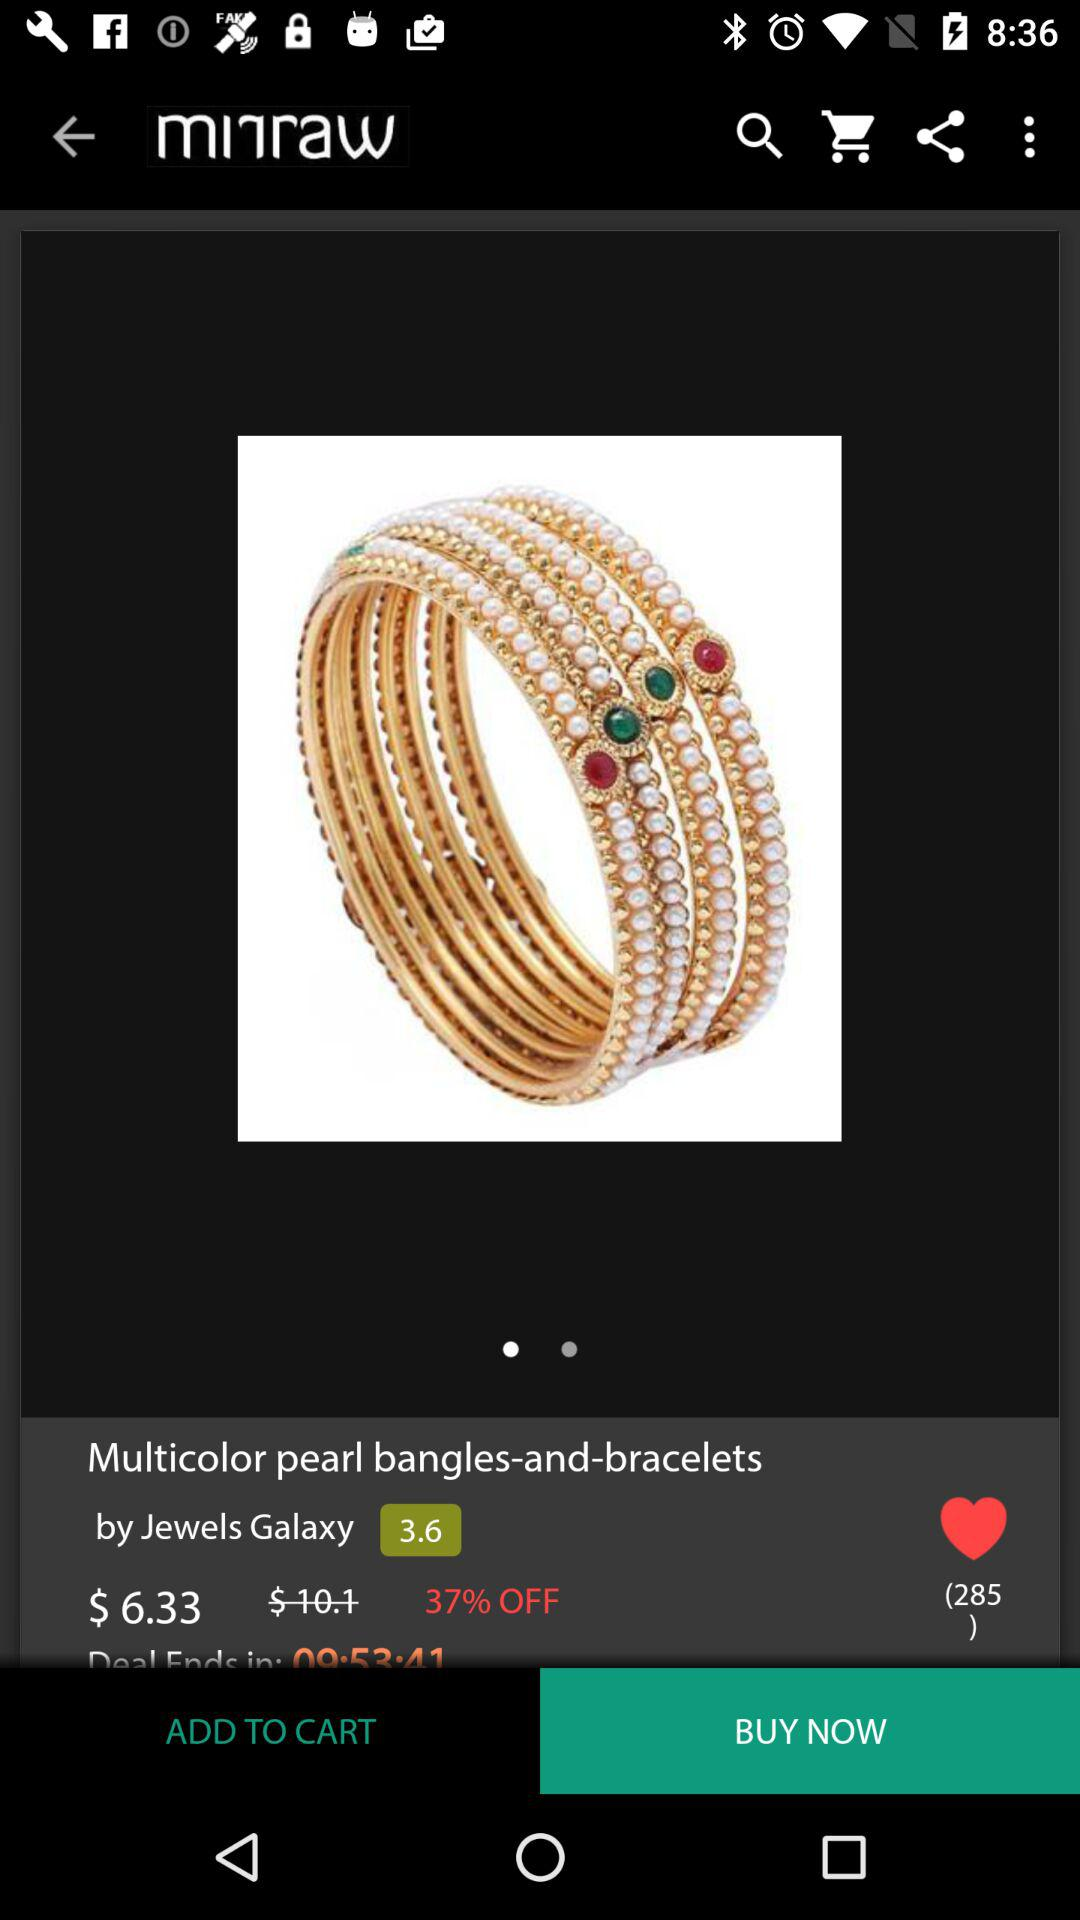How many reviews does the product have?
Answer the question using a single word or phrase. 285 